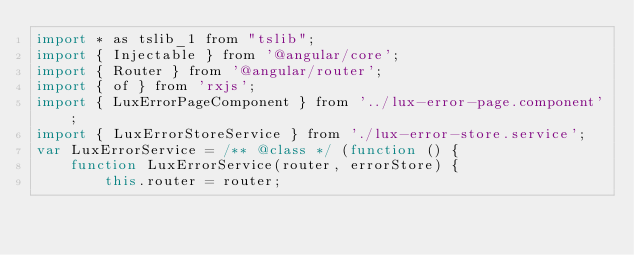Convert code to text. <code><loc_0><loc_0><loc_500><loc_500><_JavaScript_>import * as tslib_1 from "tslib";
import { Injectable } from '@angular/core';
import { Router } from '@angular/router';
import { of } from 'rxjs';
import { LuxErrorPageComponent } from '../lux-error-page.component';
import { LuxErrorStoreService } from './lux-error-store.service';
var LuxErrorService = /** @class */ (function () {
    function LuxErrorService(router, errorStore) {
        this.router = router;</code> 